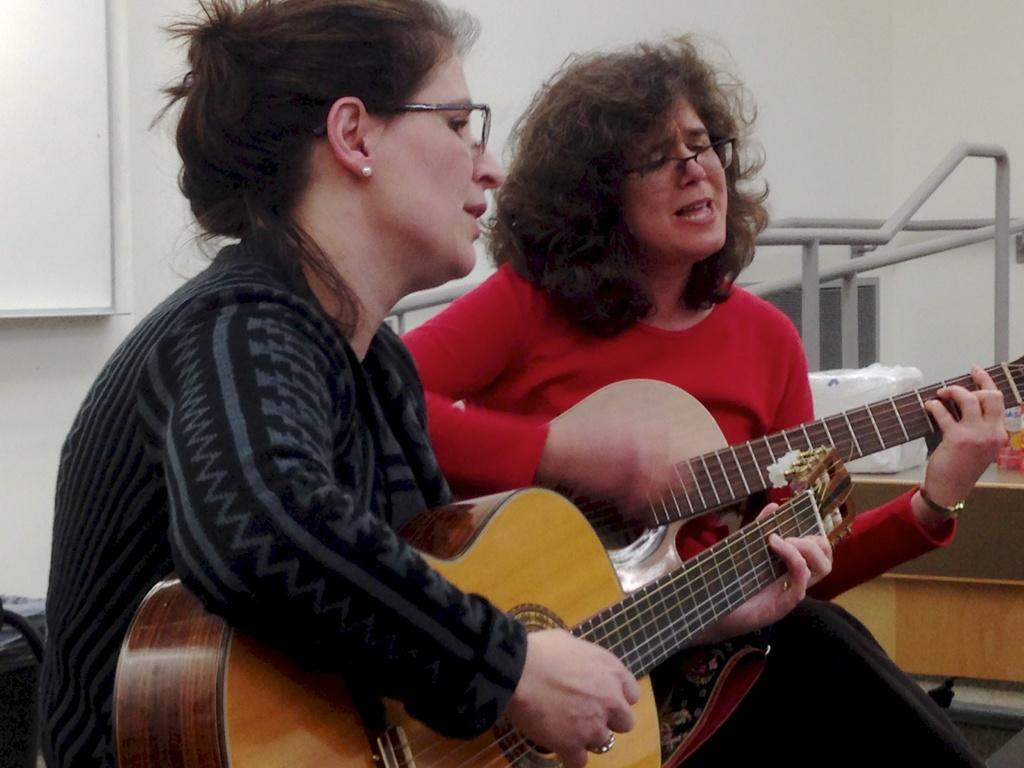How many people are in the image? There are two people in the image. What are the two people doing in the image? The two people are sitting and holding guitars. What activity are the two people engaged in? The two people are singing in the image. Where is the baby in the image? There is no baby present in the image. What type of collar can be seen on the flock of animals in the image? There is no flock of animals, nor any collars, present in the image. 